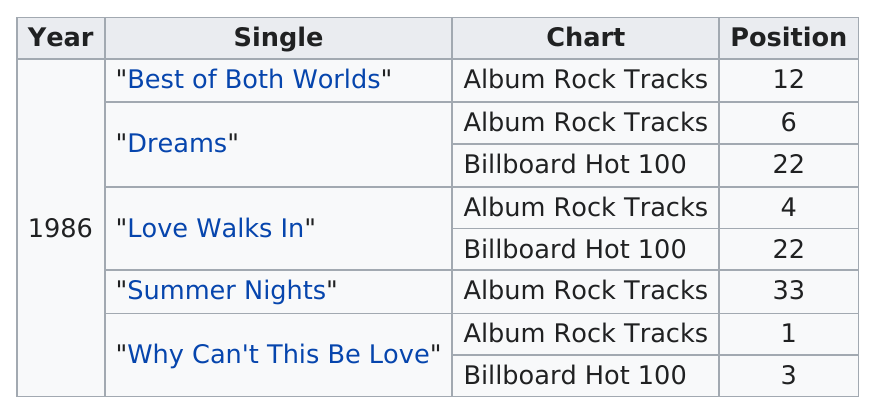Mention a couple of crucial points in this snapshot. The songs 'Dreams' and 'Love Walks In' each appear at position 22 on the respective charts. The most popular single on the album is "Why Can't This Be Love?" due to its catchy beat and memorable lyrics that have resonated with listeners. 